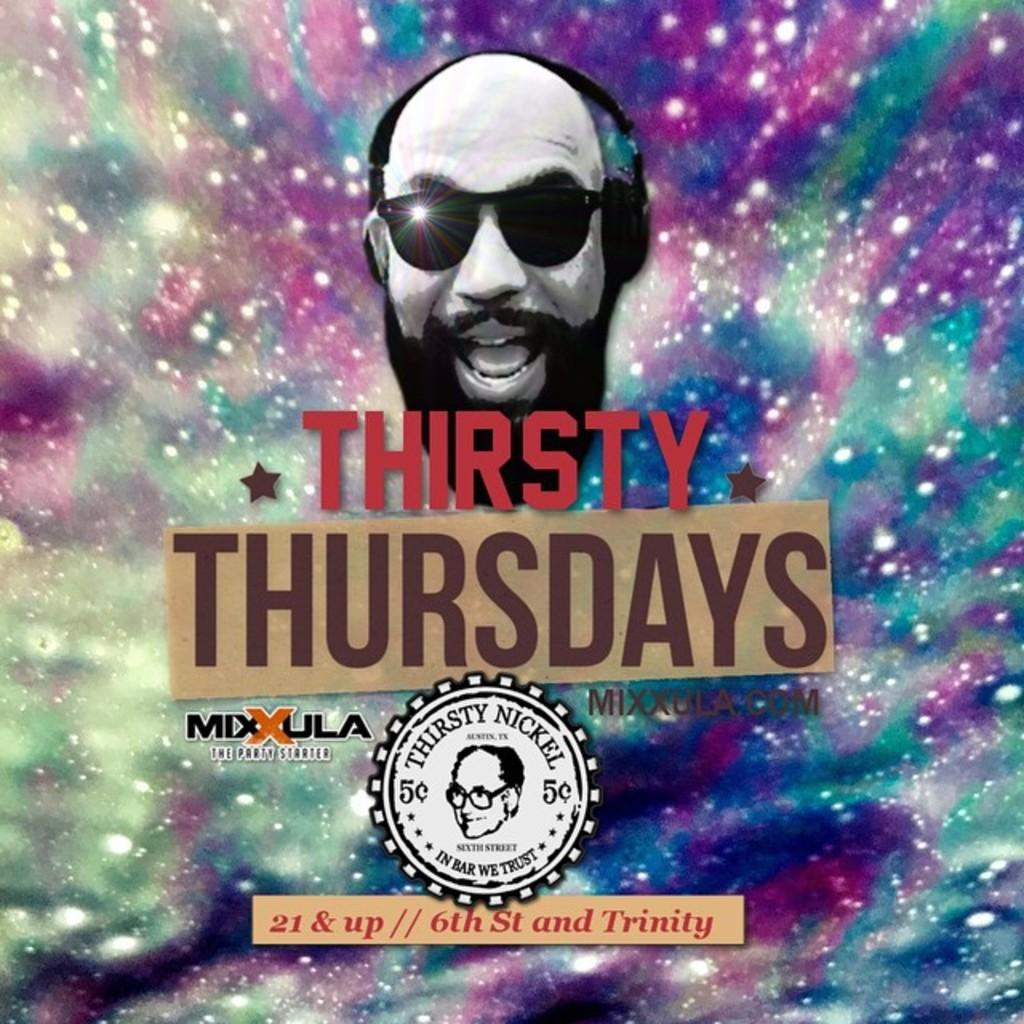What is the main subject of the poster in the image? The poster features a human face wearing goggles. Are there any additional elements on the poster? Yes, there is a stamp on the poster. What is depicted on the stamp? The stamp also features a human face. How much money is being exchanged between the police and the person in the bed in the image? There is no police or person in a bed present in the image; it only features a poster with a human face wearing goggles and a stamp with a human face. 